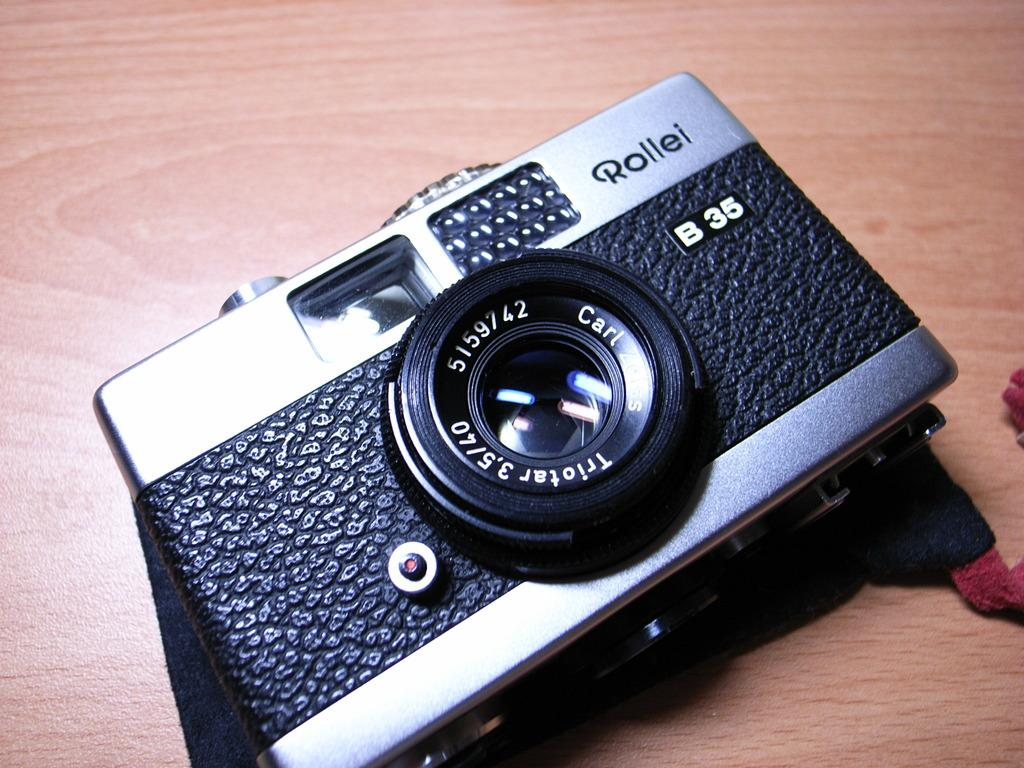What object is the main focus of the image? There is a camera in the image. Is there any text visible on the camera? Yes, there is text on the camera. On what surface is the camera placed? The camera is placed on a surface that resembles a table. What type of amusement can be seen in the image? There is no amusement present in the image; it features a camera with text on it, placed on a table-like surface. What relation does the camera have to the person in the image? There is no person present in the image, so it is impossible to determine any relation between the camera and a person. 